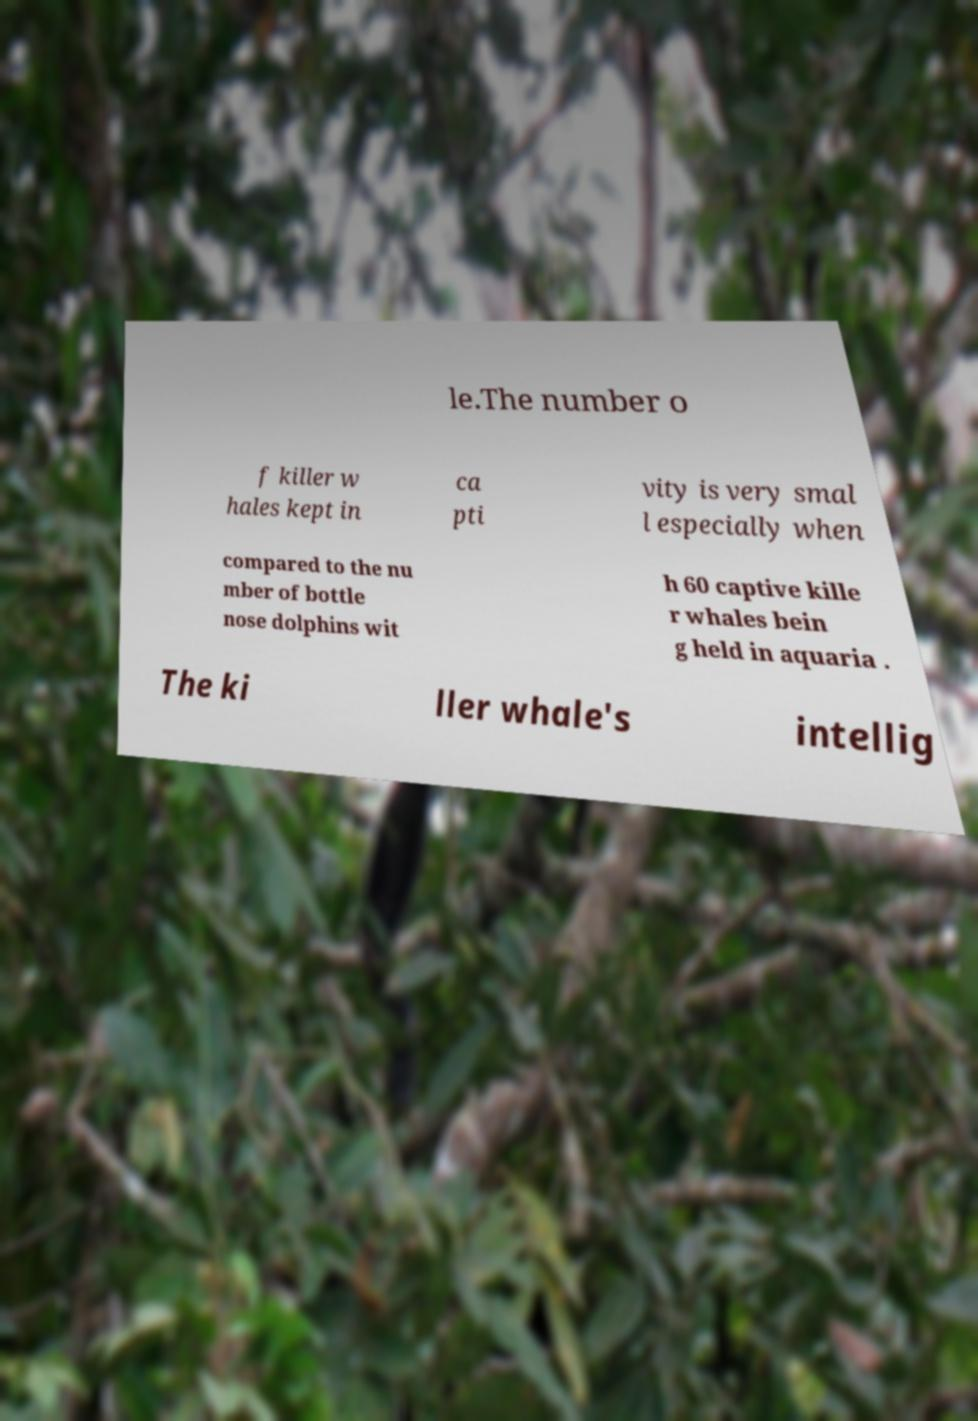What messages or text are displayed in this image? I need them in a readable, typed format. le.The number o f killer w hales kept in ca pti vity is very smal l especially when compared to the nu mber of bottle nose dolphins wit h 60 captive kille r whales bein g held in aquaria . The ki ller whale's intellig 